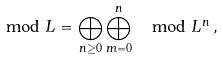Convert formula to latex. <formula><loc_0><loc_0><loc_500><loc_500>\mod L = \bigoplus _ { n \geq 0 } \bigoplus _ { m = 0 } ^ { n } \mod L ^ { n } \, ,</formula> 